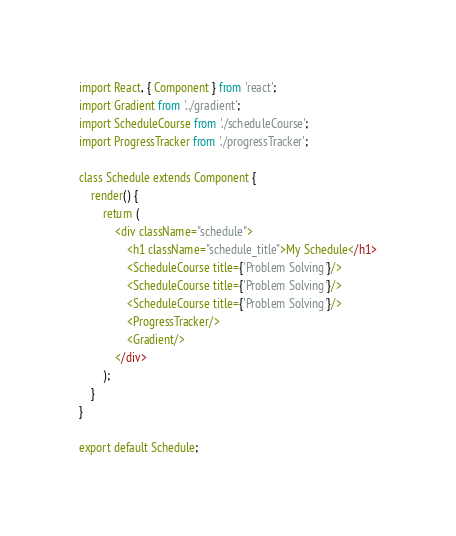<code> <loc_0><loc_0><loc_500><loc_500><_JavaScript_>import React, { Component } from 'react';
import Gradient from '../gradient';
import ScheduleCourse from './scheduleCourse';
import ProgressTracker from './progressTracker';

class Schedule extends Component {
    render() {
        return (
            <div className="schedule">
                <h1 className="schedule_title">My Schedule</h1>
                <ScheduleCourse title={'Problem Solving'}/>
                <ScheduleCourse title={'Problem Solving'}/>
                <ScheduleCourse title={'Problem Solving'}/>
                <ProgressTracker/>
                <Gradient/>
            </div>
        );
    }
}

export default Schedule;</code> 